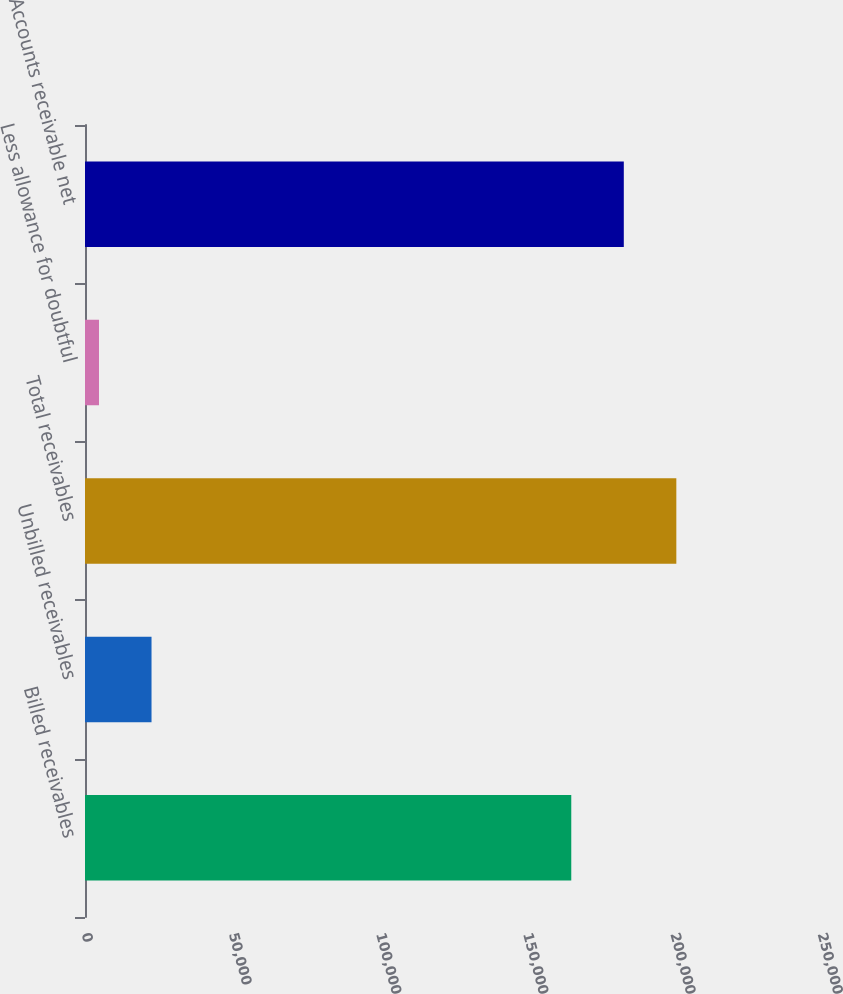Convert chart. <chart><loc_0><loc_0><loc_500><loc_500><bar_chart><fcel>Billed receivables<fcel>Unbilled receivables<fcel>Total receivables<fcel>Less allowance for doubtful<fcel>Accounts receivable net<nl><fcel>165174<fcel>22596<fcel>200860<fcel>4753<fcel>183017<nl></chart> 